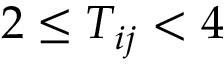Convert formula to latex. <formula><loc_0><loc_0><loc_500><loc_500>2 \leq T _ { i j } < 4</formula> 